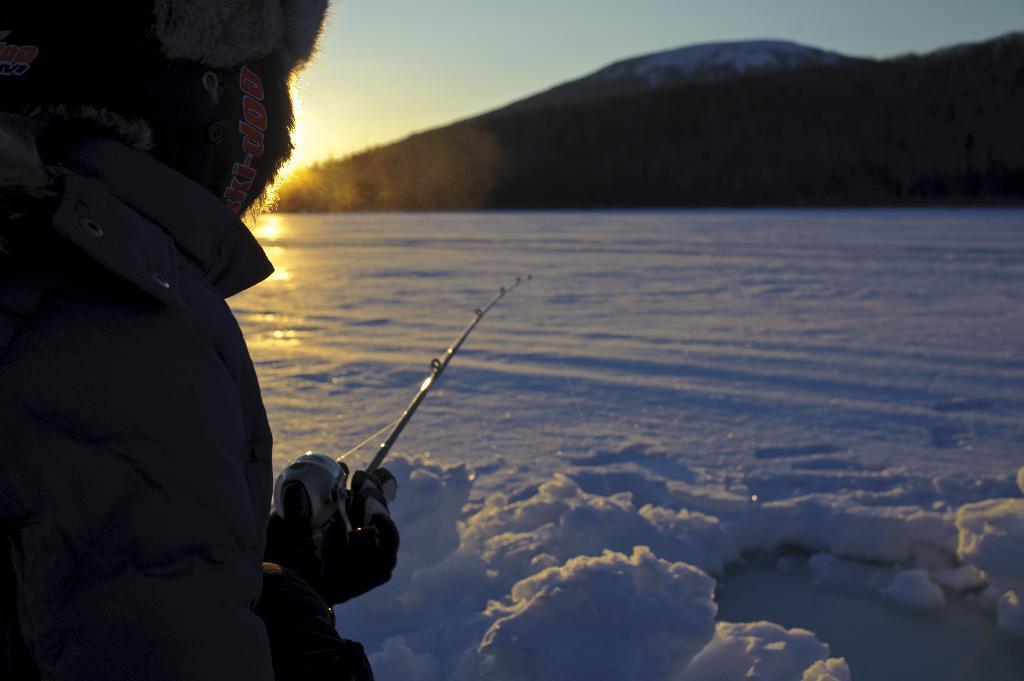Describe this image in one or two sentences. In this image, we can see a person wearing a coat and holding a stick. In the background, there are hills and trees. At the bottom, there is snow. 